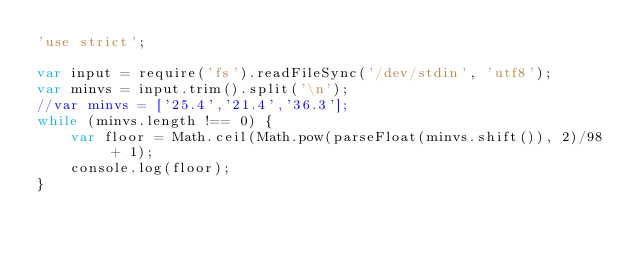Convert code to text. <code><loc_0><loc_0><loc_500><loc_500><_JavaScript_>'use strict';

var input = require('fs').readFileSync('/dev/stdin', 'utf8');
var minvs = input.trim().split('\n');
//var minvs = ['25.4','21.4','36.3'];
while (minvs.length !== 0) {
	var floor = Math.ceil(Math.pow(parseFloat(minvs.shift()), 2)/98 + 1);
	console.log(floor);
}</code> 